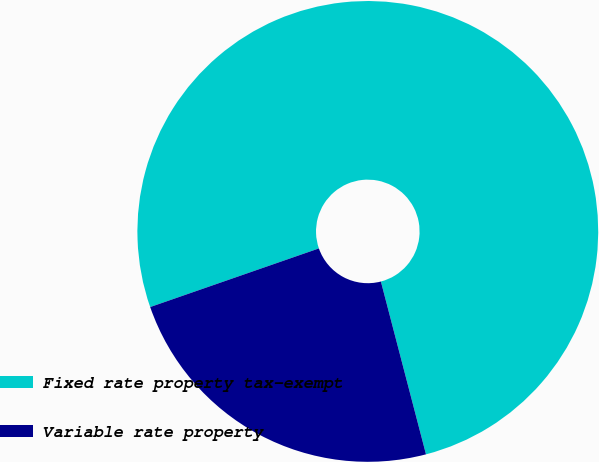Convert chart to OTSL. <chart><loc_0><loc_0><loc_500><loc_500><pie_chart><fcel>Fixed rate property tax-exempt<fcel>Variable rate property<nl><fcel>76.26%<fcel>23.74%<nl></chart> 